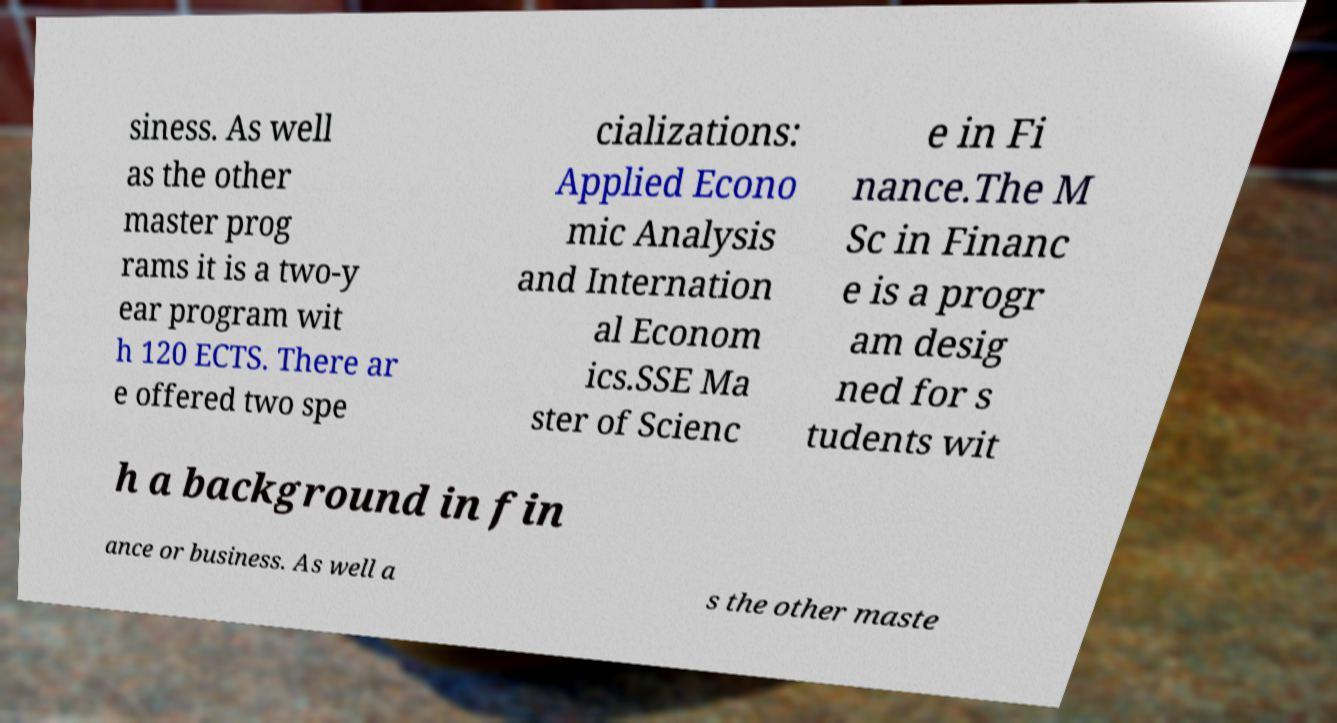Please read and relay the text visible in this image. What does it say? siness. As well as the other master prog rams it is a two-y ear program wit h 120 ECTS. There ar e offered two spe cializations: Applied Econo mic Analysis and Internation al Econom ics.SSE Ma ster of Scienc e in Fi nance.The M Sc in Financ e is a progr am desig ned for s tudents wit h a background in fin ance or business. As well a s the other maste 